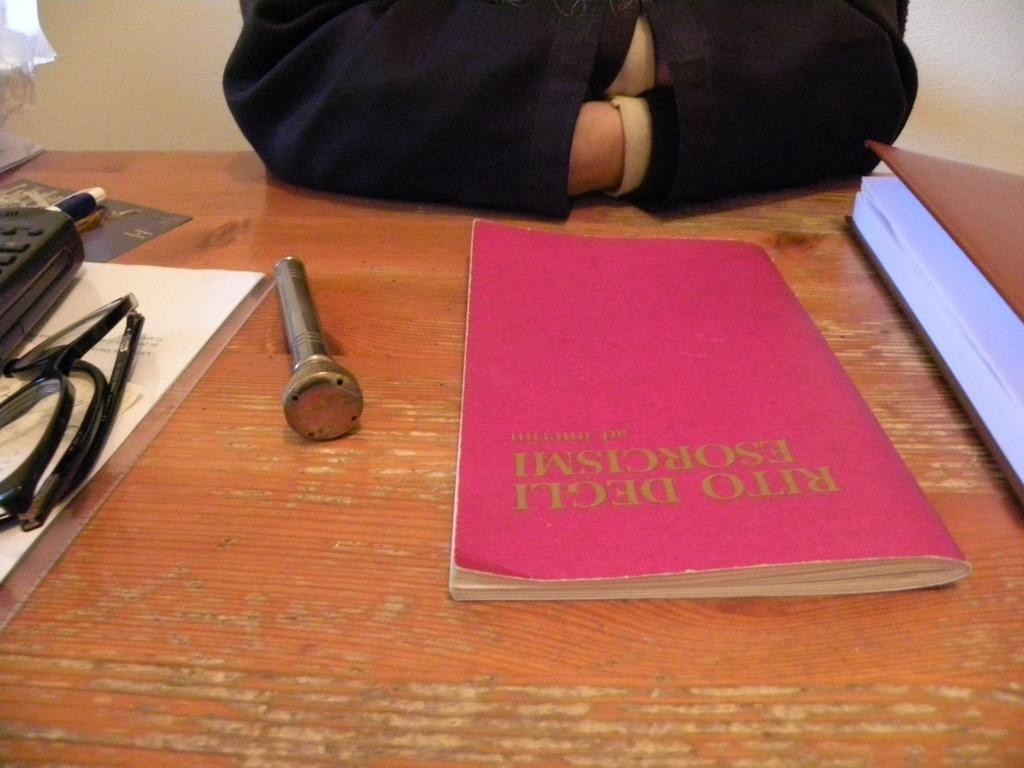<image>
Render a clear and concise summary of the photo. A person sits in front of a booklet called Rito Degli EsorcismI. 